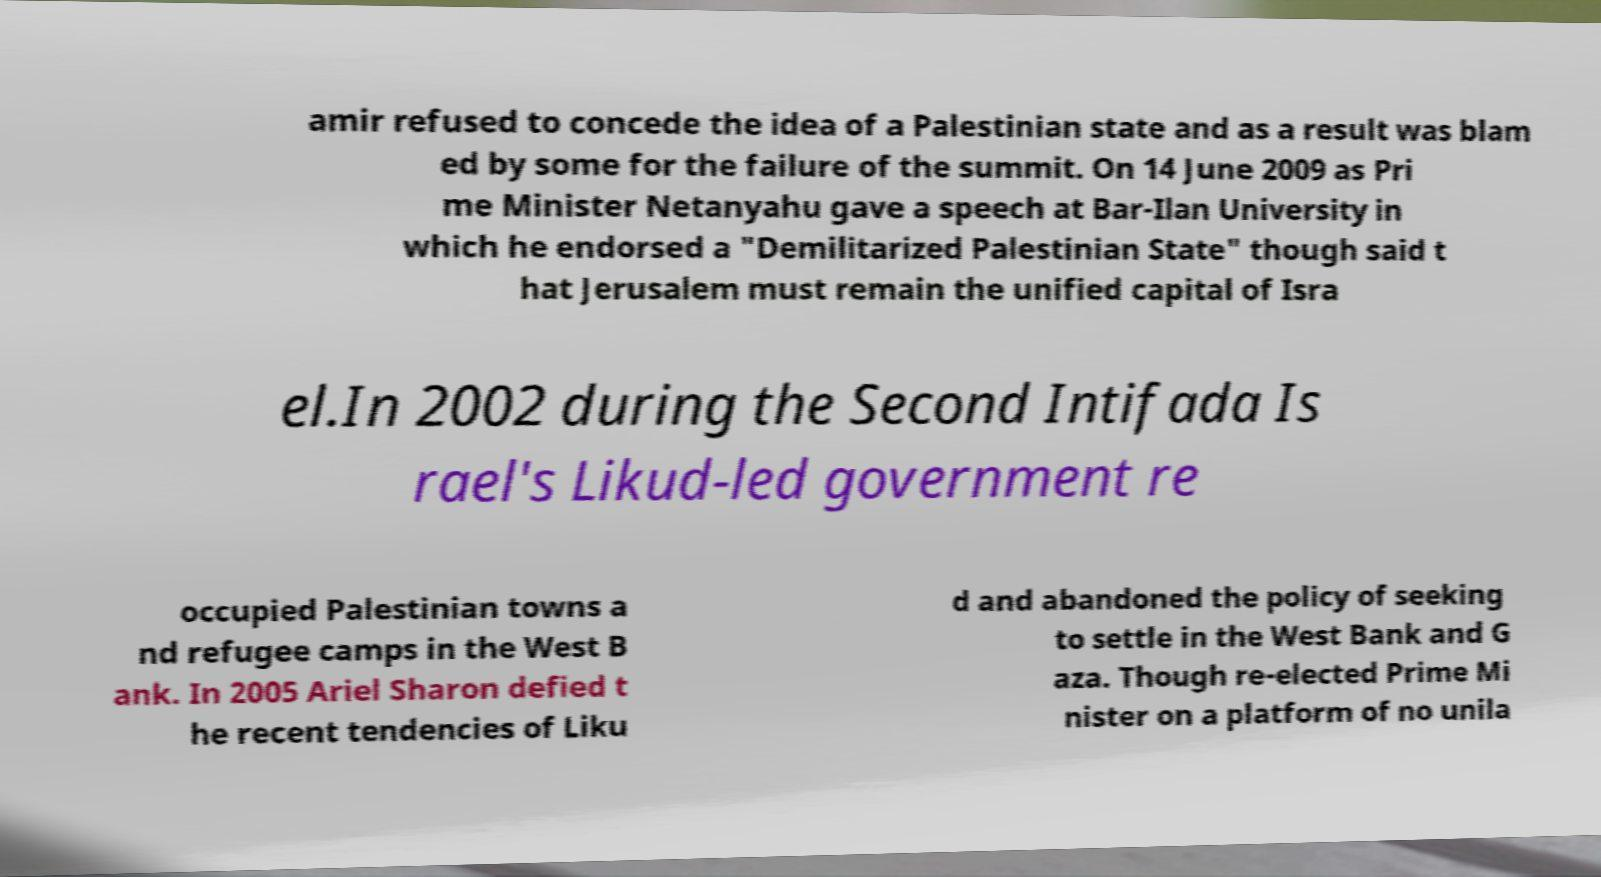Please read and relay the text visible in this image. What does it say? amir refused to concede the idea of a Palestinian state and as a result was blam ed by some for the failure of the summit. On 14 June 2009 as Pri me Minister Netanyahu gave a speech at Bar-Ilan University in which he endorsed a "Demilitarized Palestinian State" though said t hat Jerusalem must remain the unified capital of Isra el.In 2002 during the Second Intifada Is rael's Likud-led government re occupied Palestinian towns a nd refugee camps in the West B ank. In 2005 Ariel Sharon defied t he recent tendencies of Liku d and abandoned the policy of seeking to settle in the West Bank and G aza. Though re-elected Prime Mi nister on a platform of no unila 